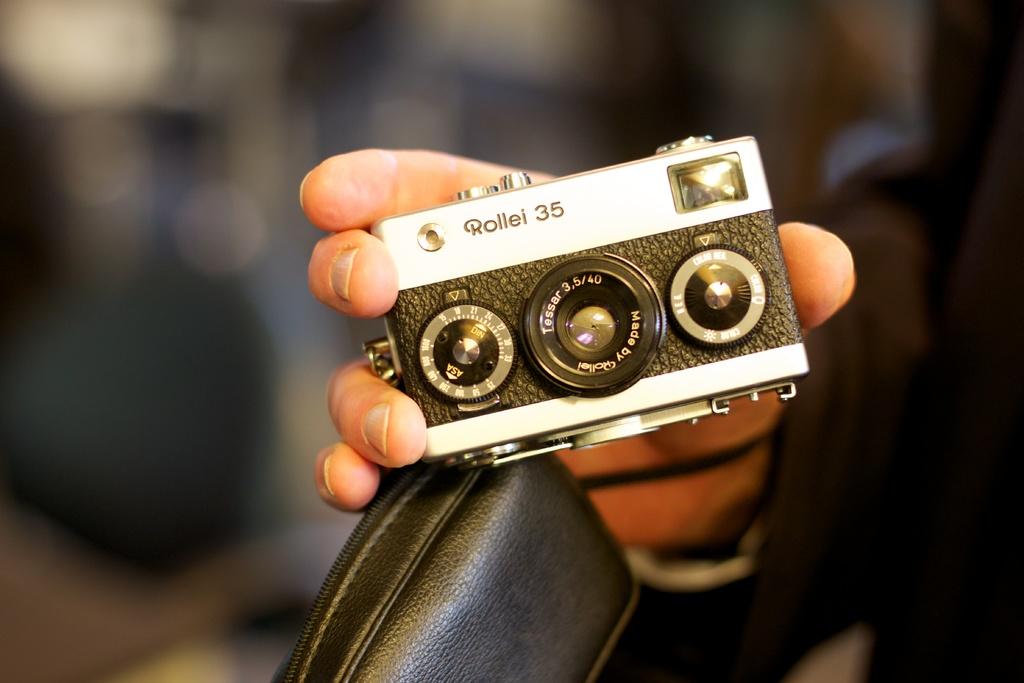What is the brand of camera?
Offer a very short reply. Rollei. 